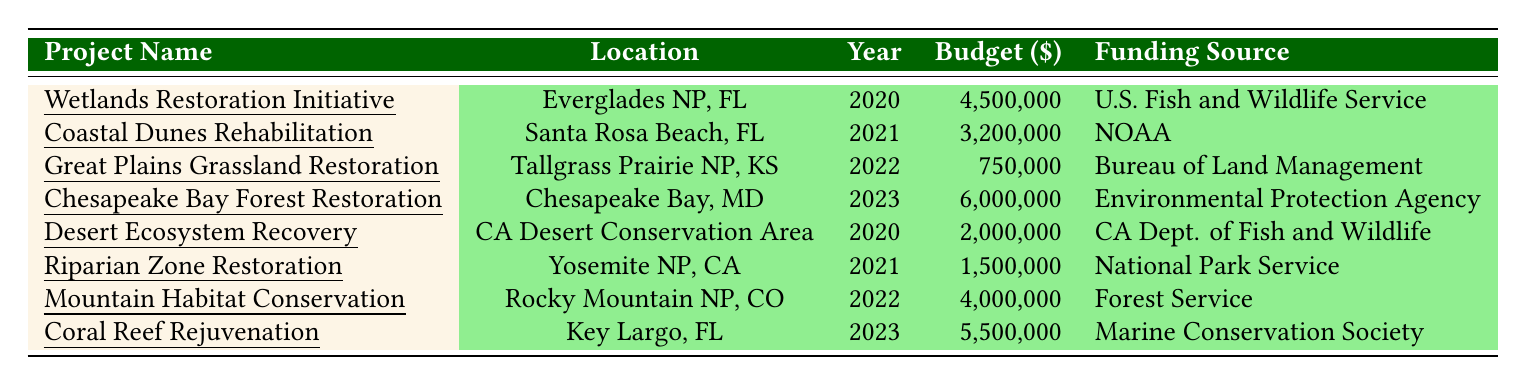What is the budget for the Wetlands Restoration Initiative? The table states that the budget for the Wetlands Restoration Initiative, located in Everglades National Park, Florida in 2020, is 4,500,000 dollars.
Answer: 4,500,000 Which project received funding from the National Oceanic and Atmospheric Administration? The Coastal Dunes Rehabilitation project, located in Santa Rosa Beach, Florida in 2021, received funding from the National Oceanic and Atmospheric Administration.
Answer: Coastal Dunes Rehabilitation What is the total budget for projects in 2022? The total budget for projects in 2022 includes the Great Plains Grassland Restoration (750,000) and Mountain Habitat Conservation (4,000,000). Adding them gives 750,000 + 4,000,000 = 4,750,000 dollars.
Answer: 4,750,000 Did any project in 2023 have a budget lower than 6 million? Yes, the Coral Reef Rejuvenation project, with a budget of 5,500,000 dollars, had a budget lower than 6 million.
Answer: Yes Which funding source was used for the Mountain Habitat Conservation project? The table indicates that the Mountain Habitat Conservation project, located in Rocky Mountain National Park, Colorado in 2022, was funded by the Forest Service.
Answer: Forest Service What is the average budget of the projects funded in 2020? The projects funded in 2020 are Wetlands Restoration Initiative (4,500,000) and Desert Ecosystem Recovery (2,000,000). The sum is 4,500,000 + 2,000,000 = 6,500,000. There are 2 projects, so the average budget is 6,500,000 / 2 = 3,250,000 dollars.
Answer: 3,250,000 How does the budget for Chesapeake Bay Forest Restoration compare to the average budget of all projects listed? The budget for Chesapeake Bay Forest Restoration is 6,000,000 dollars. We first find the sum of all budgets: (4,500,000 + 3,200,000 + 750,000 + 6,000,000 + 2,000,000 + 1,500,000 + 4,000,000 + 5,500,000) = 27,450,000. There are 8 projects, so the average is 27,450,000 / 8 = 3,431,250 dollars. Comparing, 6,000,000 (Chesapeake Bay) is greater than 3,431,250.
Answer: It is greater Which state had projects funded by the Environmental Protection Agency? The table shows that the Chesapeake Bay Forest Restoration project, located in Chesapeake Bay, Maryland, was funded by the Environmental Protection Agency.
Answer: Maryland 